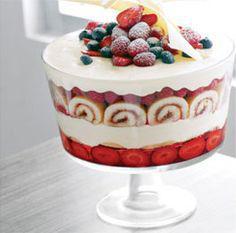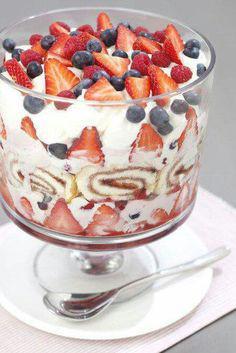The first image is the image on the left, the second image is the image on the right. Evaluate the accuracy of this statement regarding the images: "the desserts have rolled up cake involved". Is it true? Answer yes or no. Yes. 